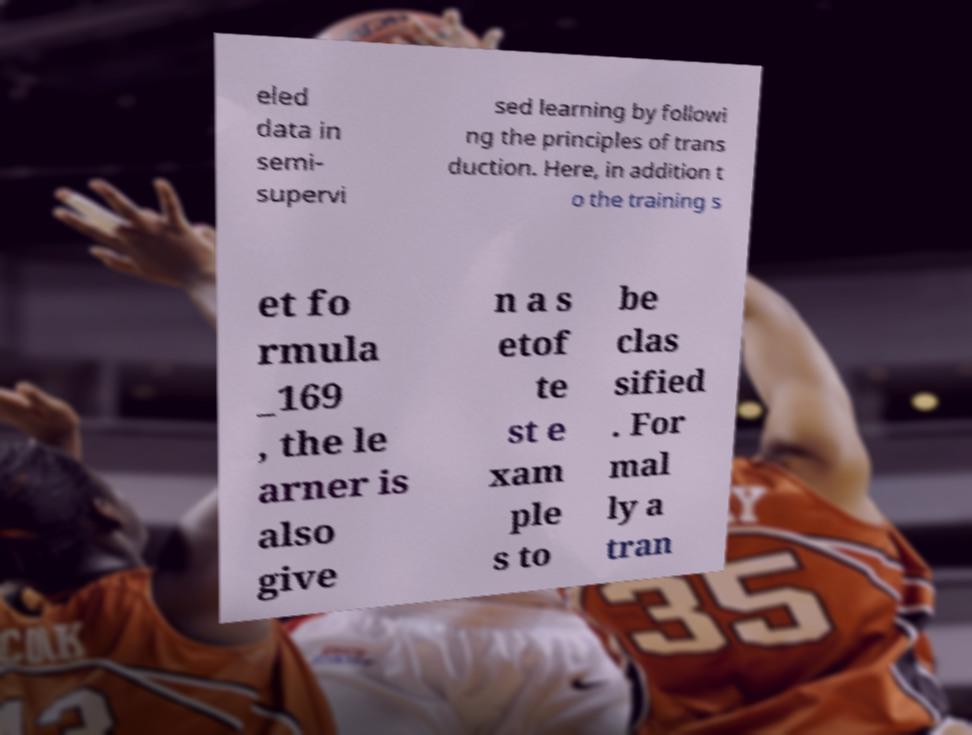There's text embedded in this image that I need extracted. Can you transcribe it verbatim? eled data in semi- supervi sed learning by followi ng the principles of trans duction. Here, in addition t o the training s et fo rmula _169 , the le arner is also give n a s etof te st e xam ple s to be clas sified . For mal ly a tran 